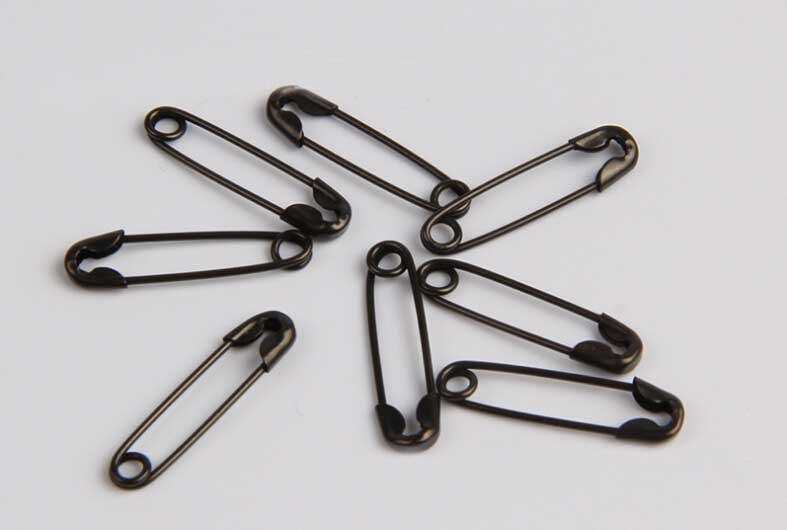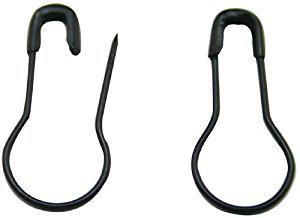The first image is the image on the left, the second image is the image on the right. Examine the images to the left and right. Is the description "There are six paperclips total." accurate? Answer yes or no. No. 